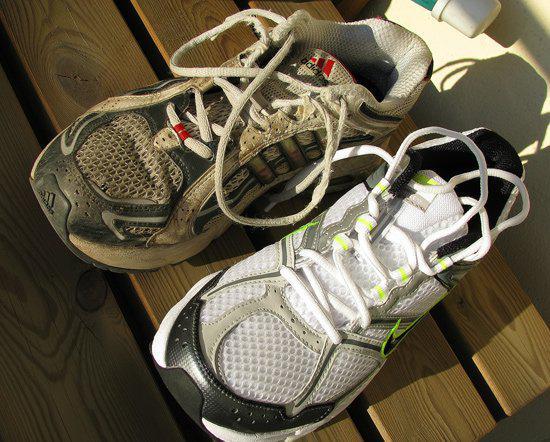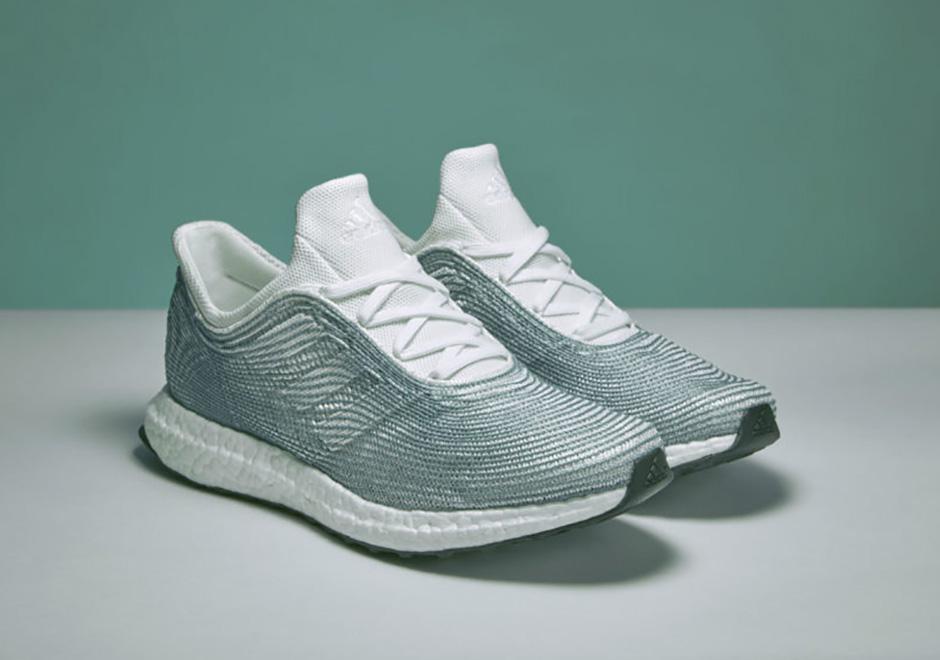The first image is the image on the left, the second image is the image on the right. Considering the images on both sides, is "One image contains one pair of new shoes, and the other image contains at least eight shoes and includes pairs." valid? Answer yes or no. No. The first image is the image on the left, the second image is the image on the right. Evaluate the accuracy of this statement regarding the images: "The left image contains at least five shoes.". Is it true? Answer yes or no. No. 